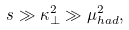<formula> <loc_0><loc_0><loc_500><loc_500>s \gg \kappa _ { \perp } ^ { 2 } \gg \mu _ { h a d } ^ { 2 } ,</formula> 